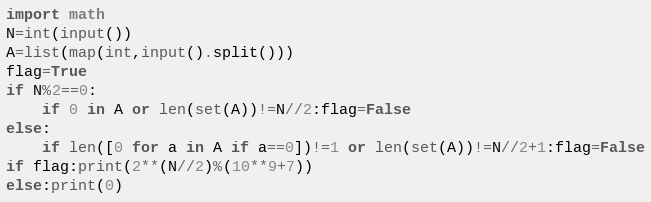Convert code to text. <code><loc_0><loc_0><loc_500><loc_500><_Python_>import math
N=int(input())
A=list(map(int,input().split()))
flag=True
if N%2==0:
    if 0 in A or len(set(A))!=N//2:flag=False
else:
    if len([0 for a in A if a==0])!=1 or len(set(A))!=N//2+1:flag=False
if flag:print(2**(N//2)%(10**9+7))
else:print(0)</code> 